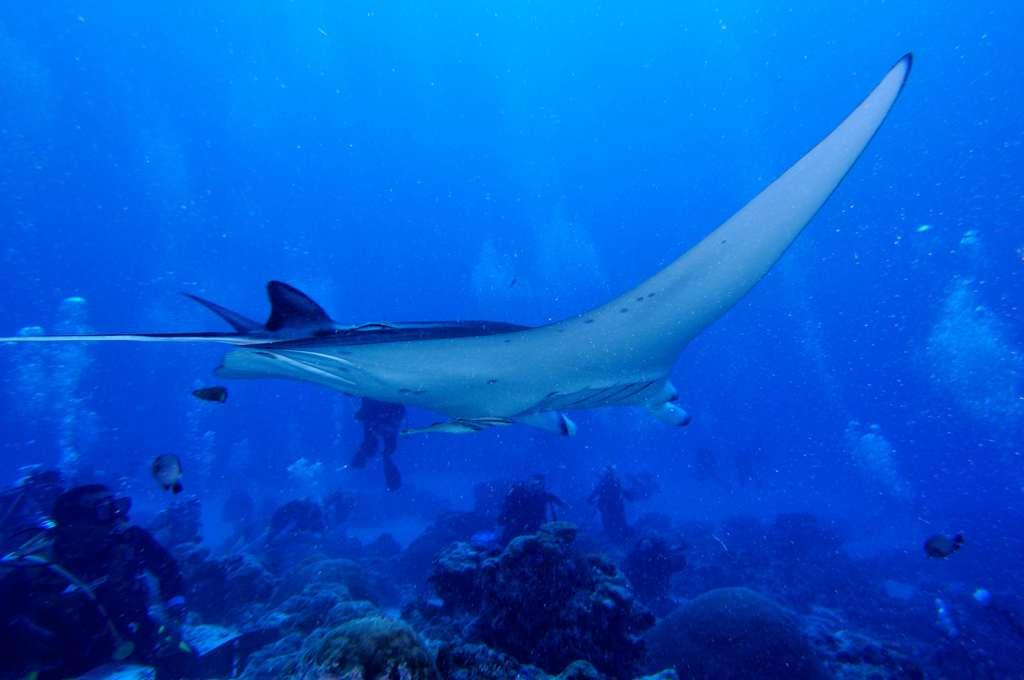What type of environment is shown in the image? The image depicts an underwater environment. What creatures can be seen in the image? There are fish in the image. Can you describe the presence of a person in the image? There is a person in the bottom left corner of the image. What type of stamp can be seen on the yak in the image? There is no stamp or yak present in the image; it depicts an underwater environment with fish and a person. How many maps are visible in the image? There are no maps present in the image. 